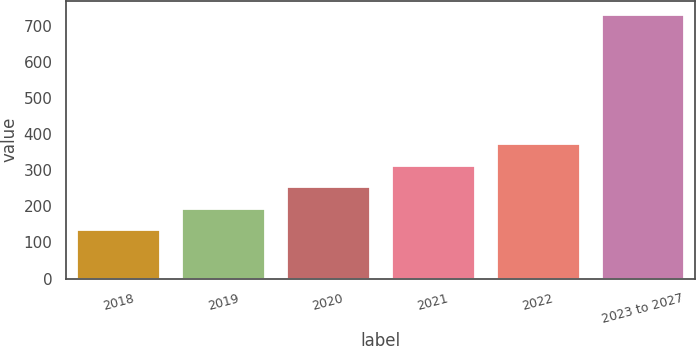<chart> <loc_0><loc_0><loc_500><loc_500><bar_chart><fcel>2018<fcel>2019<fcel>2020<fcel>2021<fcel>2022<fcel>2023 to 2027<nl><fcel>137<fcel>196.5<fcel>256<fcel>315.5<fcel>375<fcel>732<nl></chart> 